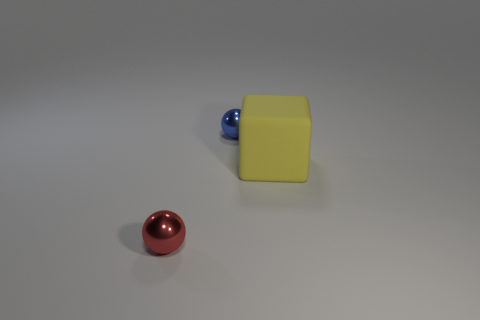Is there any significance to the positioning of the objects relative to each other? While the placement of the objects might seem arbitrary, it could be arranged to demonstrate perspectives and spatial relationships, such as foreground and background. The arrangement may also be intended to compare the textural and color contrasts between the objects. 